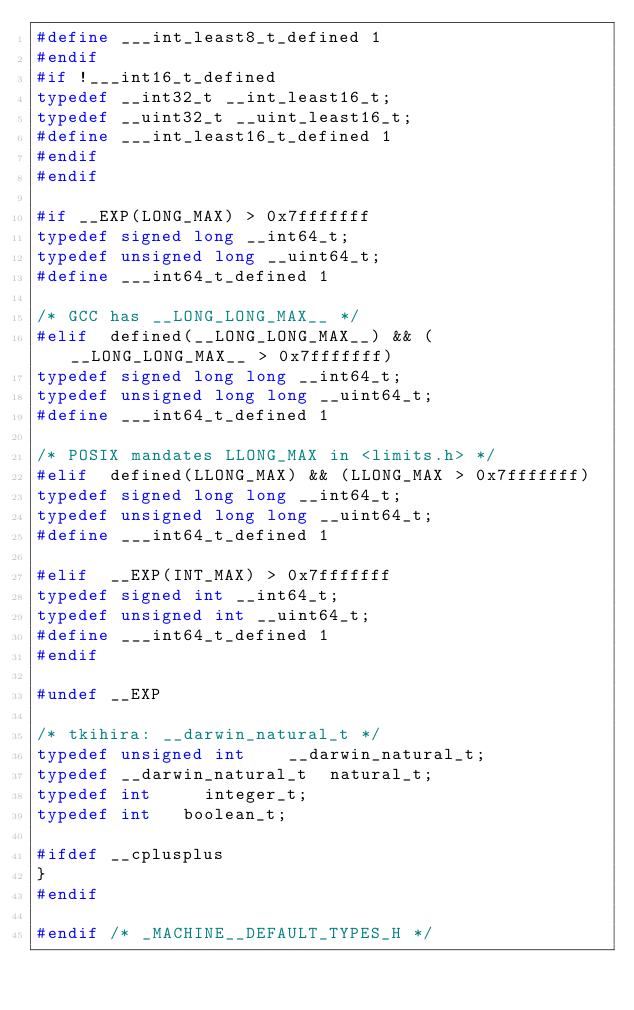<code> <loc_0><loc_0><loc_500><loc_500><_C_>#define ___int_least8_t_defined 1
#endif
#if !___int16_t_defined
typedef __int32_t __int_least16_t;
typedef __uint32_t __uint_least16_t;
#define ___int_least16_t_defined 1
#endif
#endif

#if __EXP(LONG_MAX) > 0x7fffffff
typedef signed long __int64_t;
typedef unsigned long __uint64_t;
#define ___int64_t_defined 1

/* GCC has __LONG_LONG_MAX__ */
#elif  defined(__LONG_LONG_MAX__) && (__LONG_LONG_MAX__ > 0x7fffffff)
typedef signed long long __int64_t;
typedef unsigned long long __uint64_t;
#define ___int64_t_defined 1

/* POSIX mandates LLONG_MAX in <limits.h> */
#elif  defined(LLONG_MAX) && (LLONG_MAX > 0x7fffffff)
typedef signed long long __int64_t;
typedef unsigned long long __uint64_t;
#define ___int64_t_defined 1

#elif  __EXP(INT_MAX) > 0x7fffffff
typedef signed int __int64_t;
typedef unsigned int __uint64_t;
#define ___int64_t_defined 1
#endif

#undef __EXP

/* tkihira: __darwin_natural_t */
typedef unsigned int		__darwin_natural_t;
typedef __darwin_natural_t	natural_t;
typedef int			integer_t;
typedef int		boolean_t;

#ifdef __cplusplus
}
#endif

#endif /* _MACHINE__DEFAULT_TYPES_H */
</code> 